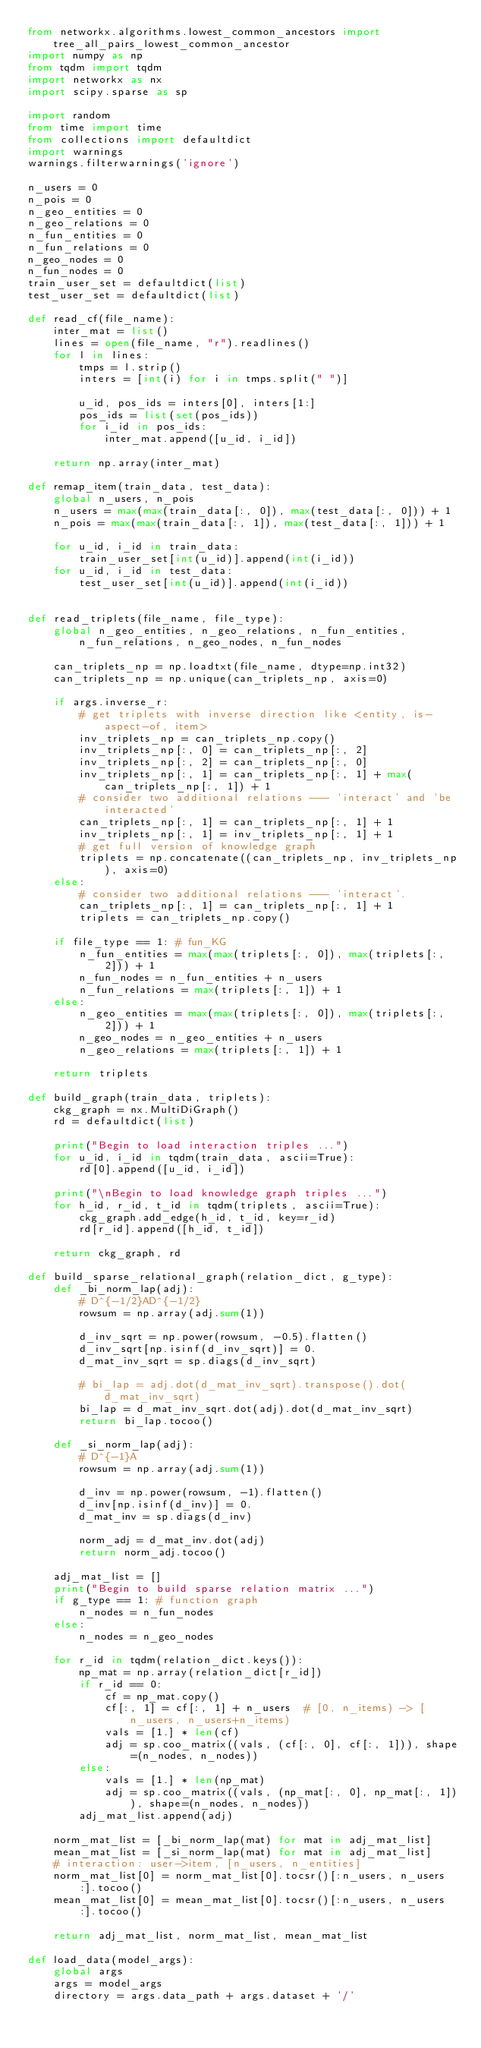Convert code to text. <code><loc_0><loc_0><loc_500><loc_500><_Python_>from networkx.algorithms.lowest_common_ancestors import tree_all_pairs_lowest_common_ancestor
import numpy as np
from tqdm import tqdm
import networkx as nx
import scipy.sparse as sp

import random
from time import time
from collections import defaultdict
import warnings
warnings.filterwarnings('ignore')

n_users = 0
n_pois = 0
n_geo_entities = 0
n_geo_relations = 0
n_fun_entities = 0
n_fun_relations = 0
n_geo_nodes = 0
n_fun_nodes = 0
train_user_set = defaultdict(list)
test_user_set = defaultdict(list)

def read_cf(file_name):
    inter_mat = list()
    lines = open(file_name, "r").readlines()
    for l in lines:
        tmps = l.strip()
        inters = [int(i) for i in tmps.split(" ")]

        u_id, pos_ids = inters[0], inters[1:]
        pos_ids = list(set(pos_ids))
        for i_id in pos_ids:
            inter_mat.append([u_id, i_id])

    return np.array(inter_mat)

def remap_item(train_data, test_data):
    global n_users, n_pois
    n_users = max(max(train_data[:, 0]), max(test_data[:, 0])) + 1
    n_pois = max(max(train_data[:, 1]), max(test_data[:, 1])) + 1

    for u_id, i_id in train_data:
        train_user_set[int(u_id)].append(int(i_id))
    for u_id, i_id in test_data:
        test_user_set[int(u_id)].append(int(i_id))


def read_triplets(file_name, file_type):
    global n_geo_entities, n_geo_relations, n_fun_entities, n_fun_relations, n_geo_nodes, n_fun_nodes

    can_triplets_np = np.loadtxt(file_name, dtype=np.int32)
    can_triplets_np = np.unique(can_triplets_np, axis=0)

    if args.inverse_r:
        # get triplets with inverse direction like <entity, is-aspect-of, item>
        inv_triplets_np = can_triplets_np.copy()
        inv_triplets_np[:, 0] = can_triplets_np[:, 2]
        inv_triplets_np[:, 2] = can_triplets_np[:, 0]
        inv_triplets_np[:, 1] = can_triplets_np[:, 1] + max(can_triplets_np[:, 1]) + 1
        # consider two additional relations --- 'interact' and 'be interacted'
        can_triplets_np[:, 1] = can_triplets_np[:, 1] + 1
        inv_triplets_np[:, 1] = inv_triplets_np[:, 1] + 1
        # get full version of knowledge graph
        triplets = np.concatenate((can_triplets_np, inv_triplets_np), axis=0)
    else:
        # consider two additional relations --- 'interact'.
        can_triplets_np[:, 1] = can_triplets_np[:, 1] + 1
        triplets = can_triplets_np.copy()

    if file_type == 1: # fun_KG
        n_fun_entities = max(max(triplets[:, 0]), max(triplets[:, 2])) + 1
        n_fun_nodes = n_fun_entities + n_users
        n_fun_relations = max(triplets[:, 1]) + 1
    else:
        n_geo_entities = max(max(triplets[:, 0]), max(triplets[:, 2])) + 1
        n_geo_nodes = n_geo_entities + n_users
        n_geo_relations = max(triplets[:, 1]) + 1
    
    return triplets

def build_graph(train_data, triplets):
    ckg_graph = nx.MultiDiGraph()
    rd = defaultdict(list)

    print("Begin to load interaction triples ...")
    for u_id, i_id in tqdm(train_data, ascii=True):
        rd[0].append([u_id, i_id])
    
    print("\nBegin to load knowledge graph triples ...")
    for h_id, r_id, t_id in tqdm(triplets, ascii=True):
        ckg_graph.add_edge(h_id, t_id, key=r_id)
        rd[r_id].append([h_id, t_id])
    
    return ckg_graph, rd

def build_sparse_relational_graph(relation_dict, g_type):
    def _bi_norm_lap(adj):
        # D^{-1/2}AD^{-1/2}
        rowsum = np.array(adj.sum(1))

        d_inv_sqrt = np.power(rowsum, -0.5).flatten()
        d_inv_sqrt[np.isinf(d_inv_sqrt)] = 0.
        d_mat_inv_sqrt = sp.diags(d_inv_sqrt)

        # bi_lap = adj.dot(d_mat_inv_sqrt).transpose().dot(d_mat_inv_sqrt)
        bi_lap = d_mat_inv_sqrt.dot(adj).dot(d_mat_inv_sqrt)
        return bi_lap.tocoo()

    def _si_norm_lap(adj):
        # D^{-1}A
        rowsum = np.array(adj.sum(1))

        d_inv = np.power(rowsum, -1).flatten()
        d_inv[np.isinf(d_inv)] = 0.
        d_mat_inv = sp.diags(d_inv)

        norm_adj = d_mat_inv.dot(adj)
        return norm_adj.tocoo()

    adj_mat_list = []
    print("Begin to build sparse relation matrix ...")
    if g_type == 1: # function graph
        n_nodes = n_fun_nodes
    else:
        n_nodes = n_geo_nodes

    for r_id in tqdm(relation_dict.keys()):
        np_mat = np.array(relation_dict[r_id])
        if r_id == 0:
            cf = np_mat.copy()
            cf[:, 1] = cf[:, 1] + n_users  # [0, n_items) -> [n_users, n_users+n_items)
            vals = [1.] * len(cf)
            adj = sp.coo_matrix((vals, (cf[:, 0], cf[:, 1])), shape=(n_nodes, n_nodes))
        else:
            vals = [1.] * len(np_mat)
            adj = sp.coo_matrix((vals, (np_mat[:, 0], np_mat[:, 1])), shape=(n_nodes, n_nodes))
        adj_mat_list.append(adj)

    norm_mat_list = [_bi_norm_lap(mat) for mat in adj_mat_list]
    mean_mat_list = [_si_norm_lap(mat) for mat in adj_mat_list]
    # interaction: user->item, [n_users, n_entities]
    norm_mat_list[0] = norm_mat_list[0].tocsr()[:n_users, n_users:].tocoo()
    mean_mat_list[0] = mean_mat_list[0].tocsr()[:n_users, n_users:].tocoo()

    return adj_mat_list, norm_mat_list, mean_mat_list

def load_data(model_args):
    global args
    args = model_args
    directory = args.data_path + args.dataset + '/'
</code> 